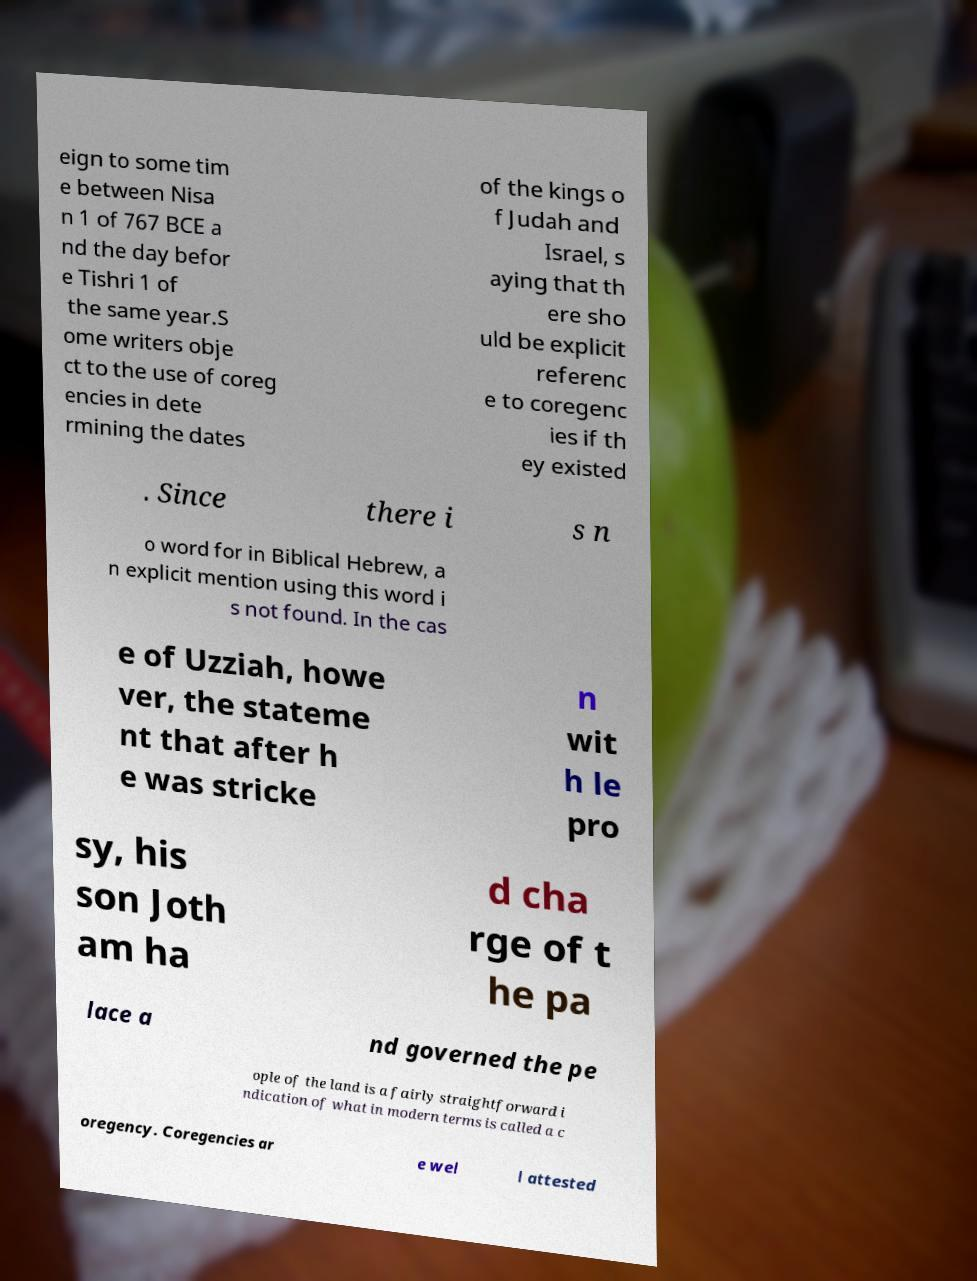There's text embedded in this image that I need extracted. Can you transcribe it verbatim? eign to some tim e between Nisa n 1 of 767 BCE a nd the day befor e Tishri 1 of the same year.S ome writers obje ct to the use of coreg encies in dete rmining the dates of the kings o f Judah and Israel, s aying that th ere sho uld be explicit referenc e to coregenc ies if th ey existed . Since there i s n o word for in Biblical Hebrew, a n explicit mention using this word i s not found. In the cas e of Uzziah, howe ver, the stateme nt that after h e was stricke n wit h le pro sy, his son Joth am ha d cha rge of t he pa lace a nd governed the pe ople of the land is a fairly straightforward i ndication of what in modern terms is called a c oregency. Coregencies ar e wel l attested 